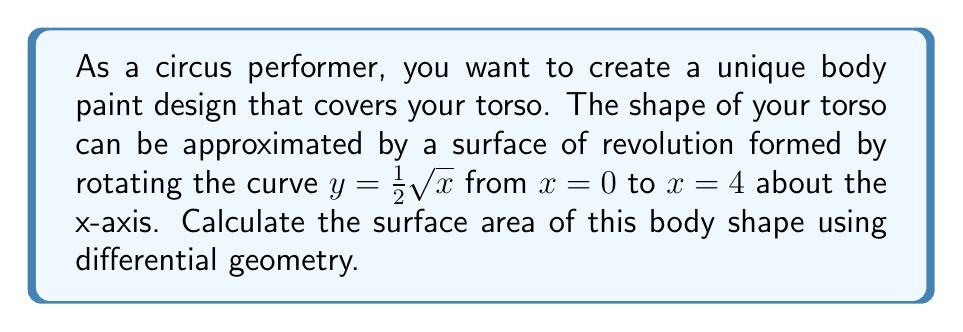Teach me how to tackle this problem. To calculate the surface area of this body shape, we'll use the formula for the surface area of a surface of revolution:

$$A = 2\pi \int_a^b y \sqrt{1 + \left(\frac{dy}{dx}\right)^2} dx$$

Where $y$ is the function being rotated, and $a$ and $b$ are the limits of integration.

Step 1: Identify the function and its derivative
$y = \frac{1}{2}\sqrt{x}$
$\frac{dy}{dx} = \frac{1}{4x^{-1/2}}$

Step 2: Set up the integral
$$A = 2\pi \int_0^4 \frac{1}{2}\sqrt{x} \sqrt{1 + \left(\frac{1}{4x^{-1/2}}\right)^2} dx$$

Step 3: Simplify the integrand
$$A = 2\pi \int_0^4 \frac{1}{2}\sqrt{x} \sqrt{1 + \frac{1}{16x}} dx$$
$$A = \pi \int_0^4 \sqrt{x + \frac{1}{16}} dx$$

Step 4: Substitute $u = x + \frac{1}{16}$, $du = dx$
$$A = \pi \int_{1/16}^{65/16} \sqrt{u} du$$

Step 5: Integrate
$$A = \pi \left[\frac{2}{3}u^{3/2}\right]_{1/16}^{65/16}$$

Step 6: Evaluate the limits
$$A = \pi \left(\frac{2}{3}\left(\frac{65}{16}\right)^{3/2} - \frac{2}{3}\left(\frac{1}{16}\right)^{3/2}\right)$$

Step 7: Simplify
$$A = \pi \left(\frac{2}{3}\cdot\frac{65\sqrt{65}}{64} - \frac{2}{3}\cdot\frac{1}{64}\right)$$
$$A = \frac{\pi}{96}(65\sqrt{65} - 1)$$
Answer: $$A = \frac{\pi}{96}(65\sqrt{65} - 1) \approx 13.51 \text{ square units}$$ 